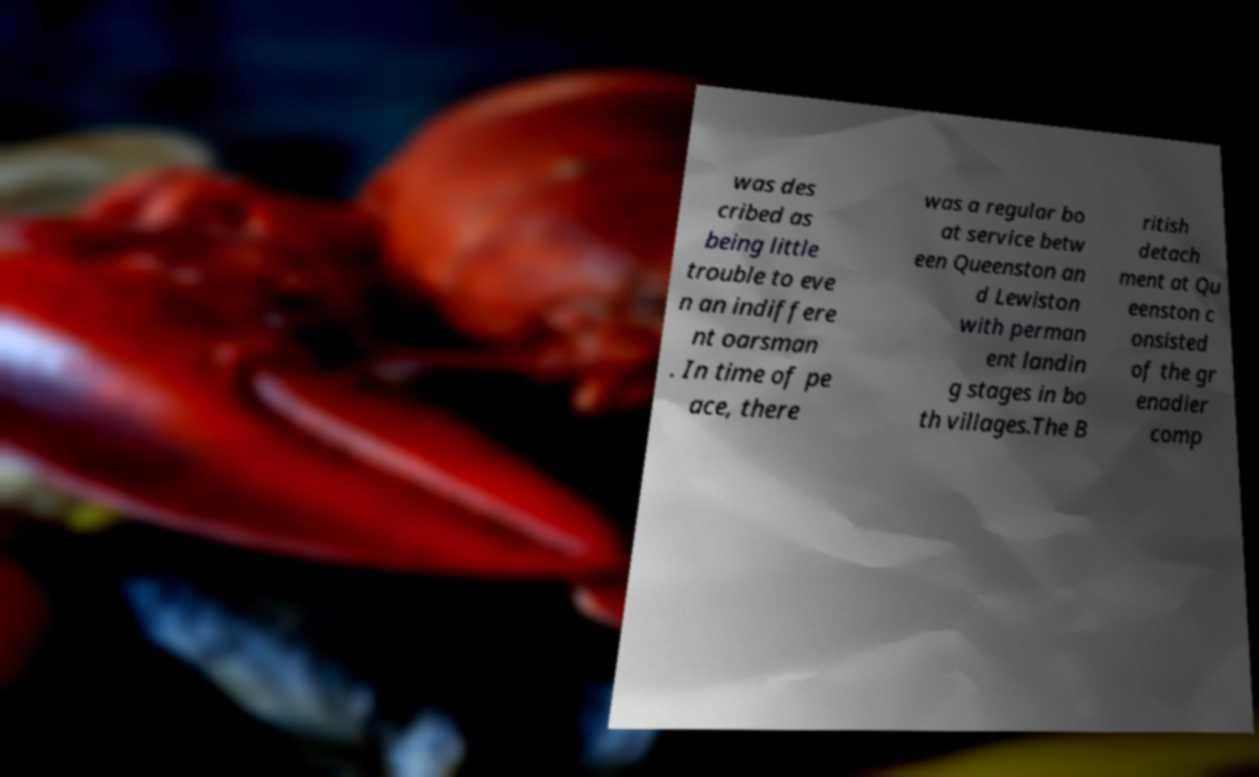Please read and relay the text visible in this image. What does it say? was des cribed as being little trouble to eve n an indiffere nt oarsman . In time of pe ace, there was a regular bo at service betw een Queenston an d Lewiston with perman ent landin g stages in bo th villages.The B ritish detach ment at Qu eenston c onsisted of the gr enadier comp 